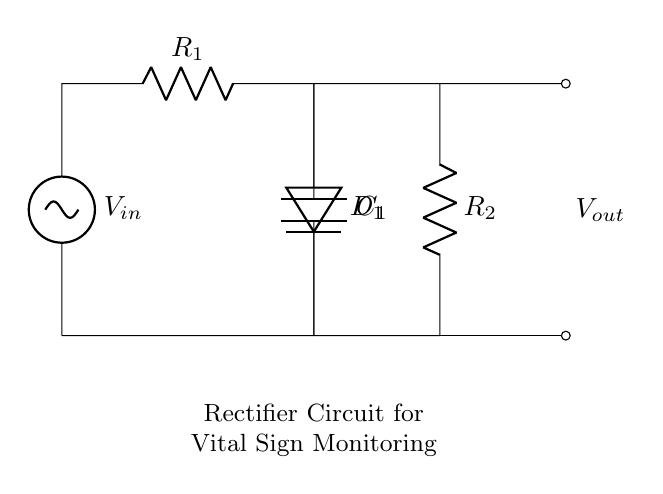What is the input voltage in this circuit? The input voltage is denoted by V_in in the diagram, which is marked on the left side of the circuit.
Answer: V_in What components are used in the rectifier circuit? The components identified in the circuit are a resistor labeled R1, a diode labeled D1, a capacitor labeled C1, and a second resistor labeled R2.
Answer: R1, D1, C1, R2 What is the purpose of the diode in this circuit? The diode, labeled D1, allows current to flow in one direction only, contributing to converting alternating current to direct current in a rectifier circuit.
Answer: Convert AC to DC What is the output voltage of the rectifier circuit? The output voltage, labeled V_out, is indicated on the right side of the circuit next to the output connections, reflecting the voltage across R2.
Answer: V_out What happens to the voltage across the capacitor during operation? The capacitor, labeled C1, charges up to a certain voltage level during the positive half-cycle and helps to smooth the output voltage, reducing fluctuations.
Answer: Smoothens voltage How does the series resistor R2 affect the output? The series resistor R2 limits the amount of current flowing to the load connected to the rectifier circuit, affecting the output voltage according to Ohm's Law.
Answer: Current limiting What is the function of the capacitor in the circuit? The capacitor C1 stores electrical energy when charged and releases it slowly, helping to stabilize the output voltage by filtering out rapid changes in voltage.
Answer: Stabilize output voltage 